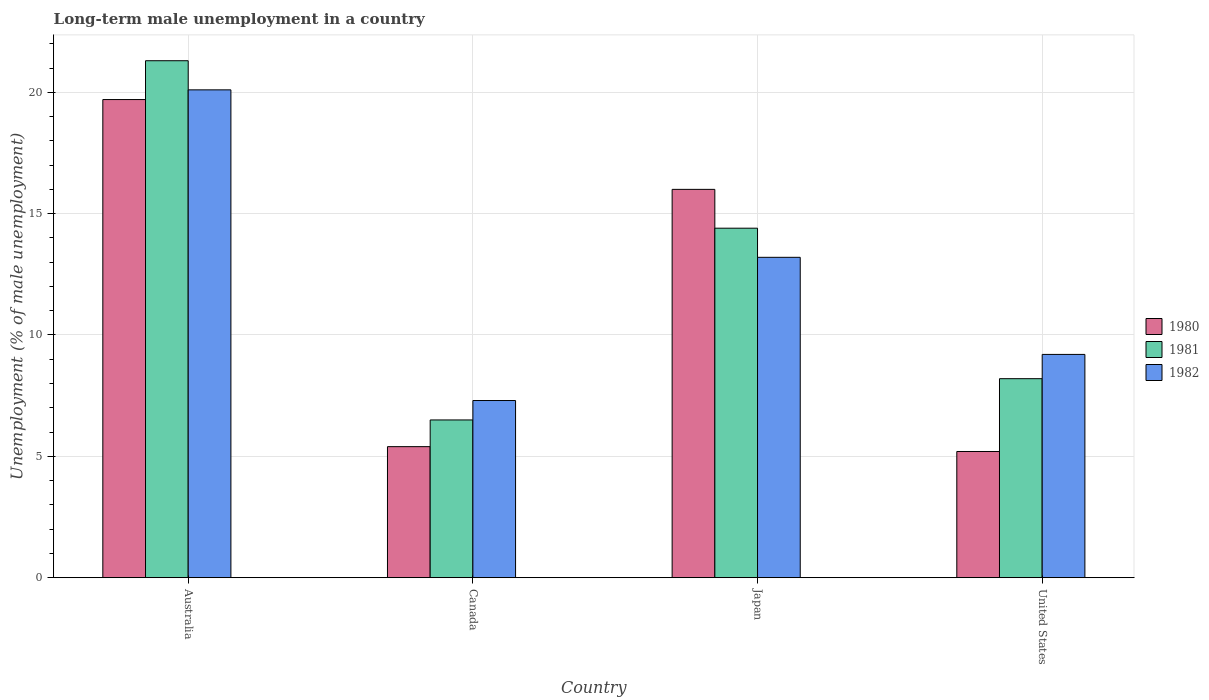How many groups of bars are there?
Ensure brevity in your answer.  4. How many bars are there on the 2nd tick from the left?
Give a very brief answer. 3. What is the label of the 2nd group of bars from the left?
Your answer should be very brief. Canada. What is the percentage of long-term unemployed male population in 1982 in Canada?
Your response must be concise. 7.3. Across all countries, what is the maximum percentage of long-term unemployed male population in 1981?
Your response must be concise. 21.3. Across all countries, what is the minimum percentage of long-term unemployed male population in 1980?
Keep it short and to the point. 5.2. In which country was the percentage of long-term unemployed male population in 1982 minimum?
Provide a short and direct response. Canada. What is the total percentage of long-term unemployed male population in 1980 in the graph?
Keep it short and to the point. 46.3. What is the difference between the percentage of long-term unemployed male population in 1980 in Australia and that in United States?
Ensure brevity in your answer.  14.5. What is the difference between the percentage of long-term unemployed male population in 1981 in Australia and the percentage of long-term unemployed male population in 1982 in United States?
Your response must be concise. 12.1. What is the average percentage of long-term unemployed male population in 1982 per country?
Keep it short and to the point. 12.45. What is the difference between the percentage of long-term unemployed male population of/in 1980 and percentage of long-term unemployed male population of/in 1981 in Japan?
Offer a terse response. 1.6. What is the ratio of the percentage of long-term unemployed male population in 1982 in Japan to that in United States?
Provide a succinct answer. 1.43. What is the difference between the highest and the second highest percentage of long-term unemployed male population in 1982?
Your answer should be very brief. -10.9. What is the difference between the highest and the lowest percentage of long-term unemployed male population in 1980?
Your answer should be compact. 14.5. What does the 3rd bar from the left in Japan represents?
Give a very brief answer. 1982. Is it the case that in every country, the sum of the percentage of long-term unemployed male population in 1982 and percentage of long-term unemployed male population in 1980 is greater than the percentage of long-term unemployed male population in 1981?
Offer a terse response. Yes. Are all the bars in the graph horizontal?
Provide a short and direct response. No. How many countries are there in the graph?
Your answer should be very brief. 4. What is the difference between two consecutive major ticks on the Y-axis?
Offer a terse response. 5. Does the graph contain any zero values?
Ensure brevity in your answer.  No. Where does the legend appear in the graph?
Make the answer very short. Center right. How many legend labels are there?
Keep it short and to the point. 3. How are the legend labels stacked?
Your answer should be compact. Vertical. What is the title of the graph?
Offer a very short reply. Long-term male unemployment in a country. Does "2008" appear as one of the legend labels in the graph?
Your response must be concise. No. What is the label or title of the X-axis?
Make the answer very short. Country. What is the label or title of the Y-axis?
Provide a short and direct response. Unemployment (% of male unemployment). What is the Unemployment (% of male unemployment) of 1980 in Australia?
Make the answer very short. 19.7. What is the Unemployment (% of male unemployment) of 1981 in Australia?
Offer a terse response. 21.3. What is the Unemployment (% of male unemployment) of 1982 in Australia?
Offer a very short reply. 20.1. What is the Unemployment (% of male unemployment) of 1980 in Canada?
Provide a short and direct response. 5.4. What is the Unemployment (% of male unemployment) in 1981 in Canada?
Give a very brief answer. 6.5. What is the Unemployment (% of male unemployment) in 1982 in Canada?
Your answer should be very brief. 7.3. What is the Unemployment (% of male unemployment) of 1981 in Japan?
Give a very brief answer. 14.4. What is the Unemployment (% of male unemployment) of 1982 in Japan?
Your answer should be compact. 13.2. What is the Unemployment (% of male unemployment) of 1980 in United States?
Keep it short and to the point. 5.2. What is the Unemployment (% of male unemployment) in 1981 in United States?
Offer a terse response. 8.2. What is the Unemployment (% of male unemployment) in 1982 in United States?
Provide a succinct answer. 9.2. Across all countries, what is the maximum Unemployment (% of male unemployment) in 1980?
Provide a succinct answer. 19.7. Across all countries, what is the maximum Unemployment (% of male unemployment) of 1981?
Your answer should be very brief. 21.3. Across all countries, what is the maximum Unemployment (% of male unemployment) in 1982?
Your response must be concise. 20.1. Across all countries, what is the minimum Unemployment (% of male unemployment) of 1980?
Your answer should be very brief. 5.2. Across all countries, what is the minimum Unemployment (% of male unemployment) in 1982?
Make the answer very short. 7.3. What is the total Unemployment (% of male unemployment) of 1980 in the graph?
Your response must be concise. 46.3. What is the total Unemployment (% of male unemployment) of 1981 in the graph?
Your answer should be compact. 50.4. What is the total Unemployment (% of male unemployment) in 1982 in the graph?
Offer a very short reply. 49.8. What is the difference between the Unemployment (% of male unemployment) of 1980 in Australia and that in Canada?
Keep it short and to the point. 14.3. What is the difference between the Unemployment (% of male unemployment) in 1980 in Australia and that in Japan?
Offer a terse response. 3.7. What is the difference between the Unemployment (% of male unemployment) in 1981 in Australia and that in Japan?
Your answer should be very brief. 6.9. What is the difference between the Unemployment (% of male unemployment) in 1982 in Australia and that in Japan?
Provide a short and direct response. 6.9. What is the difference between the Unemployment (% of male unemployment) in 1980 in Australia and that in United States?
Ensure brevity in your answer.  14.5. What is the difference between the Unemployment (% of male unemployment) in 1981 in Australia and that in United States?
Offer a very short reply. 13.1. What is the difference between the Unemployment (% of male unemployment) in 1980 in Canada and that in Japan?
Your response must be concise. -10.6. What is the difference between the Unemployment (% of male unemployment) in 1982 in Canada and that in Japan?
Provide a succinct answer. -5.9. What is the difference between the Unemployment (% of male unemployment) of 1980 in Canada and that in United States?
Ensure brevity in your answer.  0.2. What is the difference between the Unemployment (% of male unemployment) in 1981 in Canada and that in United States?
Your answer should be compact. -1.7. What is the difference between the Unemployment (% of male unemployment) of 1980 in Japan and that in United States?
Provide a succinct answer. 10.8. What is the difference between the Unemployment (% of male unemployment) in 1982 in Japan and that in United States?
Offer a very short reply. 4. What is the difference between the Unemployment (% of male unemployment) of 1980 in Australia and the Unemployment (% of male unemployment) of 1981 in Canada?
Keep it short and to the point. 13.2. What is the difference between the Unemployment (% of male unemployment) of 1980 in Australia and the Unemployment (% of male unemployment) of 1982 in Canada?
Provide a succinct answer. 12.4. What is the difference between the Unemployment (% of male unemployment) of 1980 in Australia and the Unemployment (% of male unemployment) of 1981 in Japan?
Your response must be concise. 5.3. What is the difference between the Unemployment (% of male unemployment) in 1980 in Australia and the Unemployment (% of male unemployment) in 1982 in Japan?
Make the answer very short. 6.5. What is the difference between the Unemployment (% of male unemployment) of 1980 in Australia and the Unemployment (% of male unemployment) of 1982 in United States?
Offer a terse response. 10.5. What is the difference between the Unemployment (% of male unemployment) in 1980 in Canada and the Unemployment (% of male unemployment) in 1981 in Japan?
Make the answer very short. -9. What is the difference between the Unemployment (% of male unemployment) in 1980 in Canada and the Unemployment (% of male unemployment) in 1981 in United States?
Offer a terse response. -2.8. What is the difference between the Unemployment (% of male unemployment) of 1980 in Canada and the Unemployment (% of male unemployment) of 1982 in United States?
Your answer should be compact. -3.8. What is the difference between the Unemployment (% of male unemployment) in 1981 in Canada and the Unemployment (% of male unemployment) in 1982 in United States?
Give a very brief answer. -2.7. What is the difference between the Unemployment (% of male unemployment) in 1980 in Japan and the Unemployment (% of male unemployment) in 1981 in United States?
Keep it short and to the point. 7.8. What is the difference between the Unemployment (% of male unemployment) in 1981 in Japan and the Unemployment (% of male unemployment) in 1982 in United States?
Your answer should be very brief. 5.2. What is the average Unemployment (% of male unemployment) of 1980 per country?
Ensure brevity in your answer.  11.57. What is the average Unemployment (% of male unemployment) in 1982 per country?
Provide a short and direct response. 12.45. What is the difference between the Unemployment (% of male unemployment) of 1980 and Unemployment (% of male unemployment) of 1982 in Australia?
Give a very brief answer. -0.4. What is the difference between the Unemployment (% of male unemployment) of 1980 and Unemployment (% of male unemployment) of 1981 in Japan?
Your answer should be compact. 1.6. What is the difference between the Unemployment (% of male unemployment) in 1980 and Unemployment (% of male unemployment) in 1982 in Japan?
Keep it short and to the point. 2.8. What is the difference between the Unemployment (% of male unemployment) in 1981 and Unemployment (% of male unemployment) in 1982 in United States?
Make the answer very short. -1. What is the ratio of the Unemployment (% of male unemployment) in 1980 in Australia to that in Canada?
Offer a terse response. 3.65. What is the ratio of the Unemployment (% of male unemployment) of 1981 in Australia to that in Canada?
Make the answer very short. 3.28. What is the ratio of the Unemployment (% of male unemployment) in 1982 in Australia to that in Canada?
Your answer should be very brief. 2.75. What is the ratio of the Unemployment (% of male unemployment) in 1980 in Australia to that in Japan?
Offer a terse response. 1.23. What is the ratio of the Unemployment (% of male unemployment) of 1981 in Australia to that in Japan?
Your answer should be very brief. 1.48. What is the ratio of the Unemployment (% of male unemployment) of 1982 in Australia to that in Japan?
Keep it short and to the point. 1.52. What is the ratio of the Unemployment (% of male unemployment) in 1980 in Australia to that in United States?
Ensure brevity in your answer.  3.79. What is the ratio of the Unemployment (% of male unemployment) of 1981 in Australia to that in United States?
Provide a short and direct response. 2.6. What is the ratio of the Unemployment (% of male unemployment) in 1982 in Australia to that in United States?
Your answer should be very brief. 2.18. What is the ratio of the Unemployment (% of male unemployment) in 1980 in Canada to that in Japan?
Offer a very short reply. 0.34. What is the ratio of the Unemployment (% of male unemployment) of 1981 in Canada to that in Japan?
Offer a very short reply. 0.45. What is the ratio of the Unemployment (% of male unemployment) of 1982 in Canada to that in Japan?
Provide a short and direct response. 0.55. What is the ratio of the Unemployment (% of male unemployment) in 1980 in Canada to that in United States?
Keep it short and to the point. 1.04. What is the ratio of the Unemployment (% of male unemployment) in 1981 in Canada to that in United States?
Ensure brevity in your answer.  0.79. What is the ratio of the Unemployment (% of male unemployment) in 1982 in Canada to that in United States?
Keep it short and to the point. 0.79. What is the ratio of the Unemployment (% of male unemployment) in 1980 in Japan to that in United States?
Provide a succinct answer. 3.08. What is the ratio of the Unemployment (% of male unemployment) in 1981 in Japan to that in United States?
Provide a short and direct response. 1.76. What is the ratio of the Unemployment (% of male unemployment) in 1982 in Japan to that in United States?
Offer a very short reply. 1.43. What is the difference between the highest and the second highest Unemployment (% of male unemployment) of 1980?
Your response must be concise. 3.7. What is the difference between the highest and the second highest Unemployment (% of male unemployment) of 1981?
Your response must be concise. 6.9. What is the difference between the highest and the lowest Unemployment (% of male unemployment) in 1980?
Make the answer very short. 14.5. 